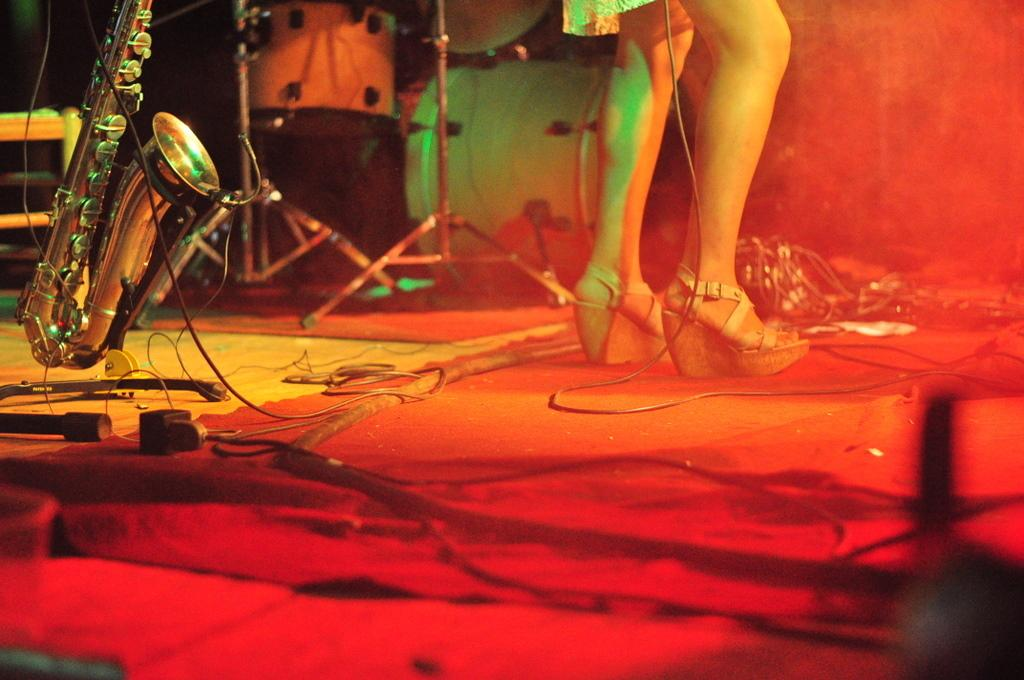What is the main subject of the image? There is a person standing in the image. What else can be seen in the image besides the person? There is a musical instrument with a stand and cables on the floor, as well as another musical instrument visible in the background of the image. What type of disease is the person in the image suffering from? There is no indication of any disease in the image; it only shows a person standing with musical instruments. Can you tell me how the person in the image is using magic to play the instruments? There is no mention of magic in the image; the person is likely playing the instruments using traditional methods. 